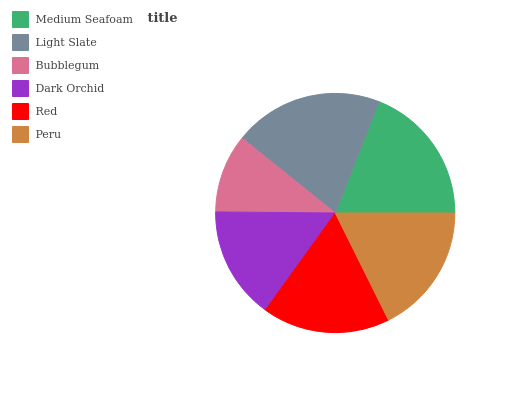Is Bubblegum the minimum?
Answer yes or no. Yes. Is Light Slate the maximum?
Answer yes or no. Yes. Is Light Slate the minimum?
Answer yes or no. No. Is Bubblegum the maximum?
Answer yes or no. No. Is Light Slate greater than Bubblegum?
Answer yes or no. Yes. Is Bubblegum less than Light Slate?
Answer yes or no. Yes. Is Bubblegum greater than Light Slate?
Answer yes or no. No. Is Light Slate less than Bubblegum?
Answer yes or no. No. Is Peru the high median?
Answer yes or no. Yes. Is Red the low median?
Answer yes or no. Yes. Is Bubblegum the high median?
Answer yes or no. No. Is Medium Seafoam the low median?
Answer yes or no. No. 